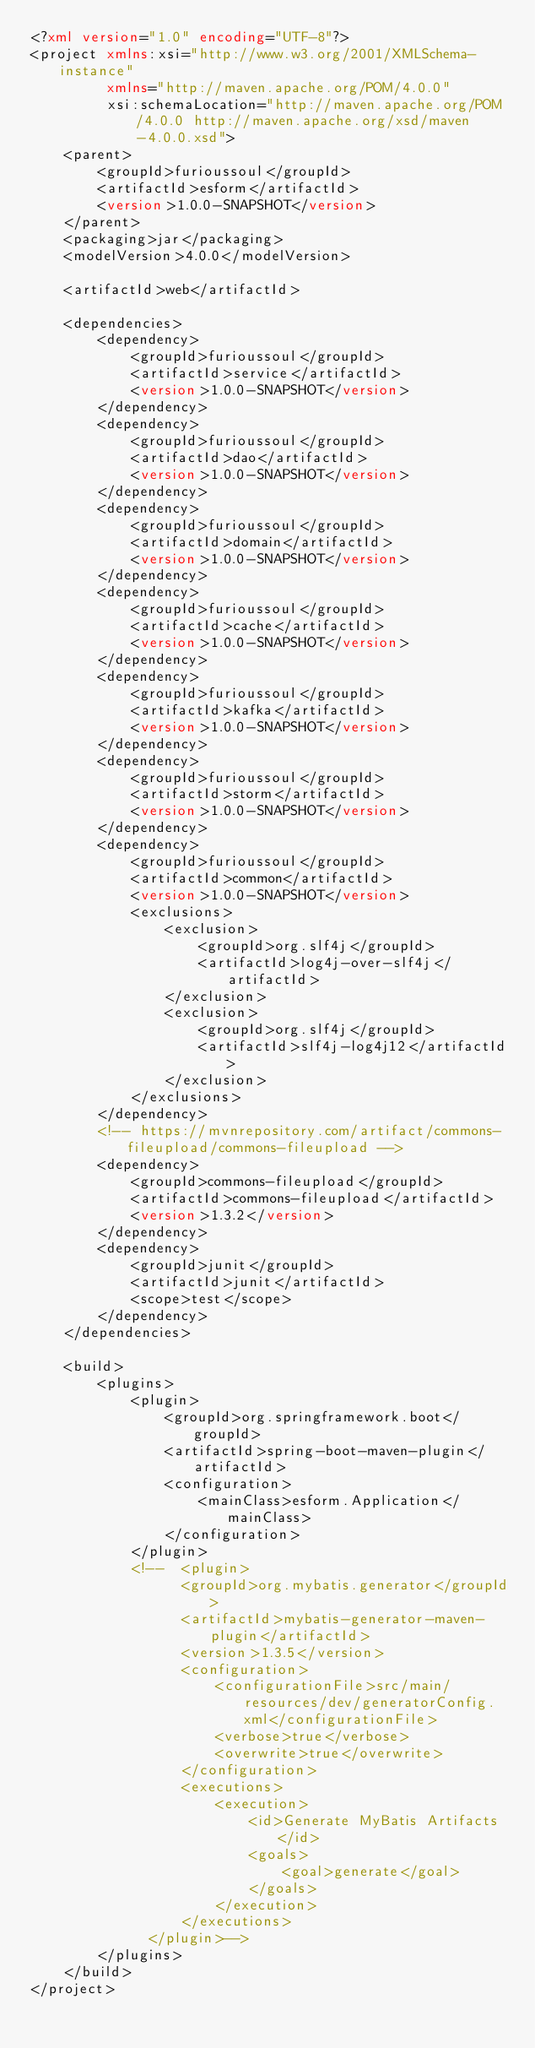Convert code to text. <code><loc_0><loc_0><loc_500><loc_500><_XML_><?xml version="1.0" encoding="UTF-8"?>
<project xmlns:xsi="http://www.w3.org/2001/XMLSchema-instance"
         xmlns="http://maven.apache.org/POM/4.0.0"
         xsi:schemaLocation="http://maven.apache.org/POM/4.0.0 http://maven.apache.org/xsd/maven-4.0.0.xsd">
    <parent>
        <groupId>furioussoul</groupId>
        <artifactId>esform</artifactId>
        <version>1.0.0-SNAPSHOT</version>
    </parent>
    <packaging>jar</packaging>
    <modelVersion>4.0.0</modelVersion>

    <artifactId>web</artifactId>

    <dependencies>
        <dependency>
            <groupId>furioussoul</groupId>
            <artifactId>service</artifactId>
            <version>1.0.0-SNAPSHOT</version>
        </dependency>
        <dependency>
            <groupId>furioussoul</groupId>
            <artifactId>dao</artifactId>
            <version>1.0.0-SNAPSHOT</version>
        </dependency>
        <dependency>
            <groupId>furioussoul</groupId>
            <artifactId>domain</artifactId>
            <version>1.0.0-SNAPSHOT</version>
        </dependency>
        <dependency>
            <groupId>furioussoul</groupId>
            <artifactId>cache</artifactId>
            <version>1.0.0-SNAPSHOT</version>
        </dependency>
        <dependency>
            <groupId>furioussoul</groupId>
            <artifactId>kafka</artifactId>
            <version>1.0.0-SNAPSHOT</version>
        </dependency>
        <dependency>
            <groupId>furioussoul</groupId>
            <artifactId>storm</artifactId>
            <version>1.0.0-SNAPSHOT</version>
        </dependency>
        <dependency>
            <groupId>furioussoul</groupId>
            <artifactId>common</artifactId>
            <version>1.0.0-SNAPSHOT</version>
            <exclusions>
                <exclusion>
                    <groupId>org.slf4j</groupId>
                    <artifactId>log4j-over-slf4j</artifactId>
                </exclusion>
                <exclusion>
                    <groupId>org.slf4j</groupId>
                    <artifactId>slf4j-log4j12</artifactId>
                </exclusion>
            </exclusions>
        </dependency>
        <!-- https://mvnrepository.com/artifact/commons-fileupload/commons-fileupload -->
        <dependency>
            <groupId>commons-fileupload</groupId>
            <artifactId>commons-fileupload</artifactId>
            <version>1.3.2</version>
        </dependency>
        <dependency>
            <groupId>junit</groupId>
            <artifactId>junit</artifactId>
            <scope>test</scope>
        </dependency>
    </dependencies>

    <build>
        <plugins>
            <plugin>
                <groupId>org.springframework.boot</groupId>
                <artifactId>spring-boot-maven-plugin</artifactId>
                <configuration>
                    <mainClass>esform.Application</mainClass>
                </configuration>
            </plugin>
            <!--  <plugin>
                  <groupId>org.mybatis.generator</groupId>
                  <artifactId>mybatis-generator-maven-plugin</artifactId>
                  <version>1.3.5</version>
                  <configuration>
                      <configurationFile>src/main/resources/dev/generatorConfig.xml</configurationFile>
                      <verbose>true</verbose>
                      <overwrite>true</overwrite>
                  </configuration>
                  <executions>
                      <execution>
                          <id>Generate MyBatis Artifacts</id>
                          <goals>
                              <goal>generate</goal>
                          </goals>
                      </execution>
                  </executions>
              </plugin>-->
        </plugins>
    </build>
</project>
</code> 